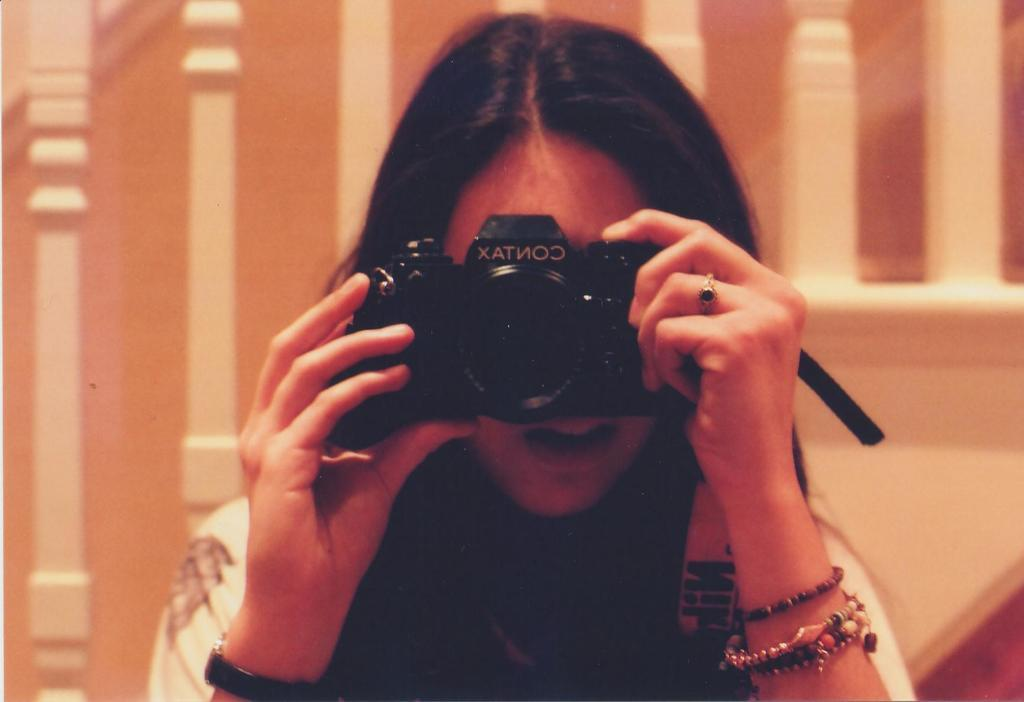Who is the main subject in the image? There is a woman in the image. What is the woman holding in the image? The woman is holding a camera. What can be seen in the background of the image? There is railing and a wall in the background of the image. How comfortable is the field in the image? There is no field present in the image; it features a woman holding a camera with railing and a wall in the background. 